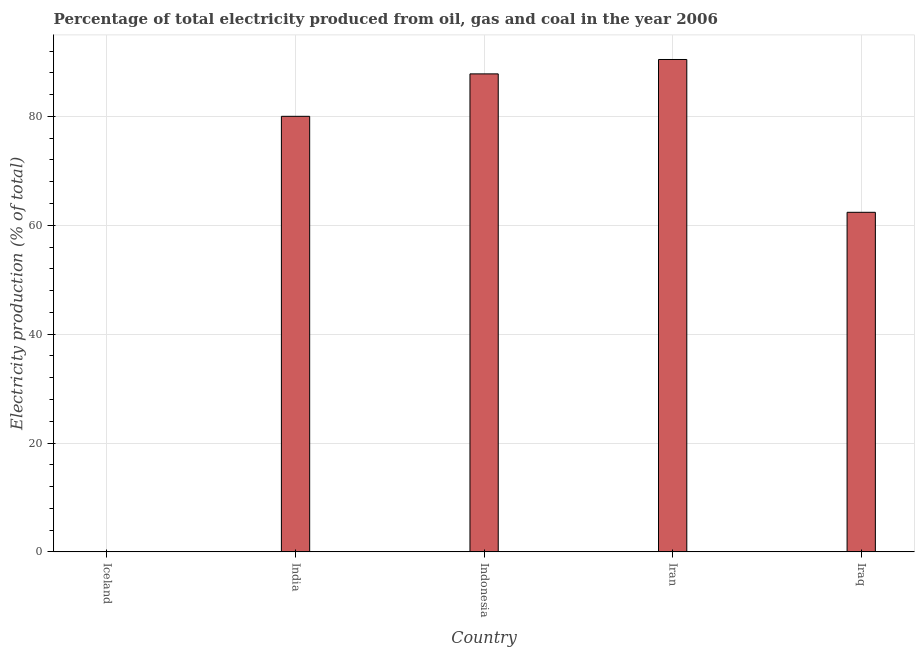Does the graph contain grids?
Your answer should be compact. Yes. What is the title of the graph?
Ensure brevity in your answer.  Percentage of total electricity produced from oil, gas and coal in the year 2006. What is the label or title of the Y-axis?
Make the answer very short. Electricity production (% of total). What is the electricity production in Iraq?
Offer a very short reply. 62.38. Across all countries, what is the maximum electricity production?
Ensure brevity in your answer.  90.46. Across all countries, what is the minimum electricity production?
Offer a terse response. 0.04. In which country was the electricity production maximum?
Make the answer very short. Iran. What is the sum of the electricity production?
Make the answer very short. 320.71. What is the difference between the electricity production in Indonesia and Iran?
Your answer should be very brief. -2.64. What is the average electricity production per country?
Keep it short and to the point. 64.14. What is the median electricity production?
Give a very brief answer. 80.02. In how many countries, is the electricity production greater than 56 %?
Your response must be concise. 4. What is the ratio of the electricity production in India to that in Indonesia?
Keep it short and to the point. 0.91. What is the difference between the highest and the second highest electricity production?
Your response must be concise. 2.64. What is the difference between the highest and the lowest electricity production?
Your answer should be compact. 90.41. How many bars are there?
Provide a short and direct response. 5. Are all the bars in the graph horizontal?
Provide a short and direct response. No. What is the difference between two consecutive major ticks on the Y-axis?
Keep it short and to the point. 20. Are the values on the major ticks of Y-axis written in scientific E-notation?
Offer a terse response. No. What is the Electricity production (% of total) of Iceland?
Your answer should be very brief. 0.04. What is the Electricity production (% of total) of India?
Make the answer very short. 80.02. What is the Electricity production (% of total) of Indonesia?
Offer a very short reply. 87.81. What is the Electricity production (% of total) of Iran?
Offer a terse response. 90.46. What is the Electricity production (% of total) of Iraq?
Your answer should be very brief. 62.38. What is the difference between the Electricity production (% of total) in Iceland and India?
Your answer should be very brief. -79.98. What is the difference between the Electricity production (% of total) in Iceland and Indonesia?
Your answer should be very brief. -87.77. What is the difference between the Electricity production (% of total) in Iceland and Iran?
Offer a terse response. -90.41. What is the difference between the Electricity production (% of total) in Iceland and Iraq?
Give a very brief answer. -62.34. What is the difference between the Electricity production (% of total) in India and Indonesia?
Make the answer very short. -7.8. What is the difference between the Electricity production (% of total) in India and Iran?
Keep it short and to the point. -10.44. What is the difference between the Electricity production (% of total) in India and Iraq?
Give a very brief answer. 17.63. What is the difference between the Electricity production (% of total) in Indonesia and Iran?
Offer a terse response. -2.64. What is the difference between the Electricity production (% of total) in Indonesia and Iraq?
Make the answer very short. 25.43. What is the difference between the Electricity production (% of total) in Iran and Iraq?
Offer a very short reply. 28.07. What is the ratio of the Electricity production (% of total) in Iceland to that in India?
Provide a short and direct response. 0. What is the ratio of the Electricity production (% of total) in Iceland to that in Indonesia?
Keep it short and to the point. 0. What is the ratio of the Electricity production (% of total) in Iceland to that in Iran?
Offer a terse response. 0. What is the ratio of the Electricity production (% of total) in Iceland to that in Iraq?
Offer a terse response. 0. What is the ratio of the Electricity production (% of total) in India to that in Indonesia?
Give a very brief answer. 0.91. What is the ratio of the Electricity production (% of total) in India to that in Iran?
Offer a very short reply. 0.89. What is the ratio of the Electricity production (% of total) in India to that in Iraq?
Your answer should be compact. 1.28. What is the ratio of the Electricity production (% of total) in Indonesia to that in Iraq?
Provide a succinct answer. 1.41. What is the ratio of the Electricity production (% of total) in Iran to that in Iraq?
Ensure brevity in your answer.  1.45. 